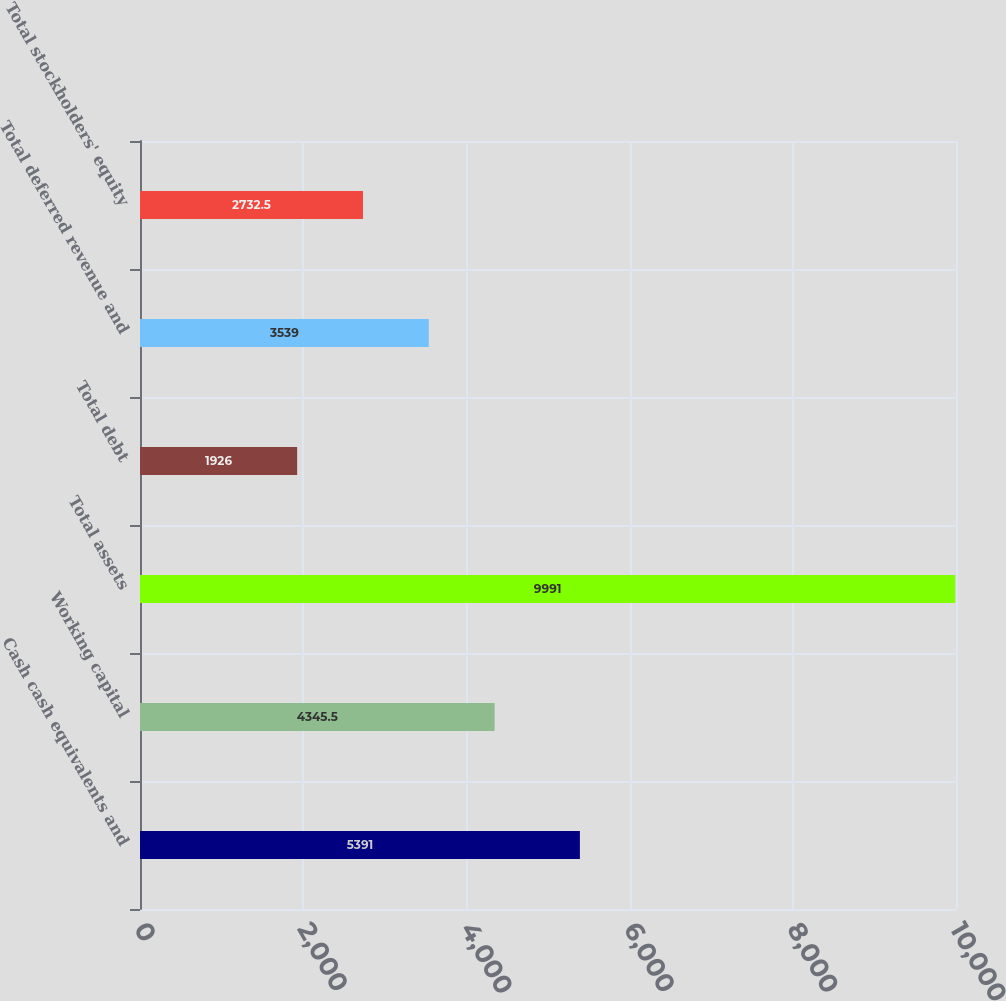Convert chart. <chart><loc_0><loc_0><loc_500><loc_500><bar_chart><fcel>Cash cash equivalents and<fcel>Working capital<fcel>Total assets<fcel>Total debt<fcel>Total deferred revenue and<fcel>Total stockholders' equity<nl><fcel>5391<fcel>4345.5<fcel>9991<fcel>1926<fcel>3539<fcel>2732.5<nl></chart> 